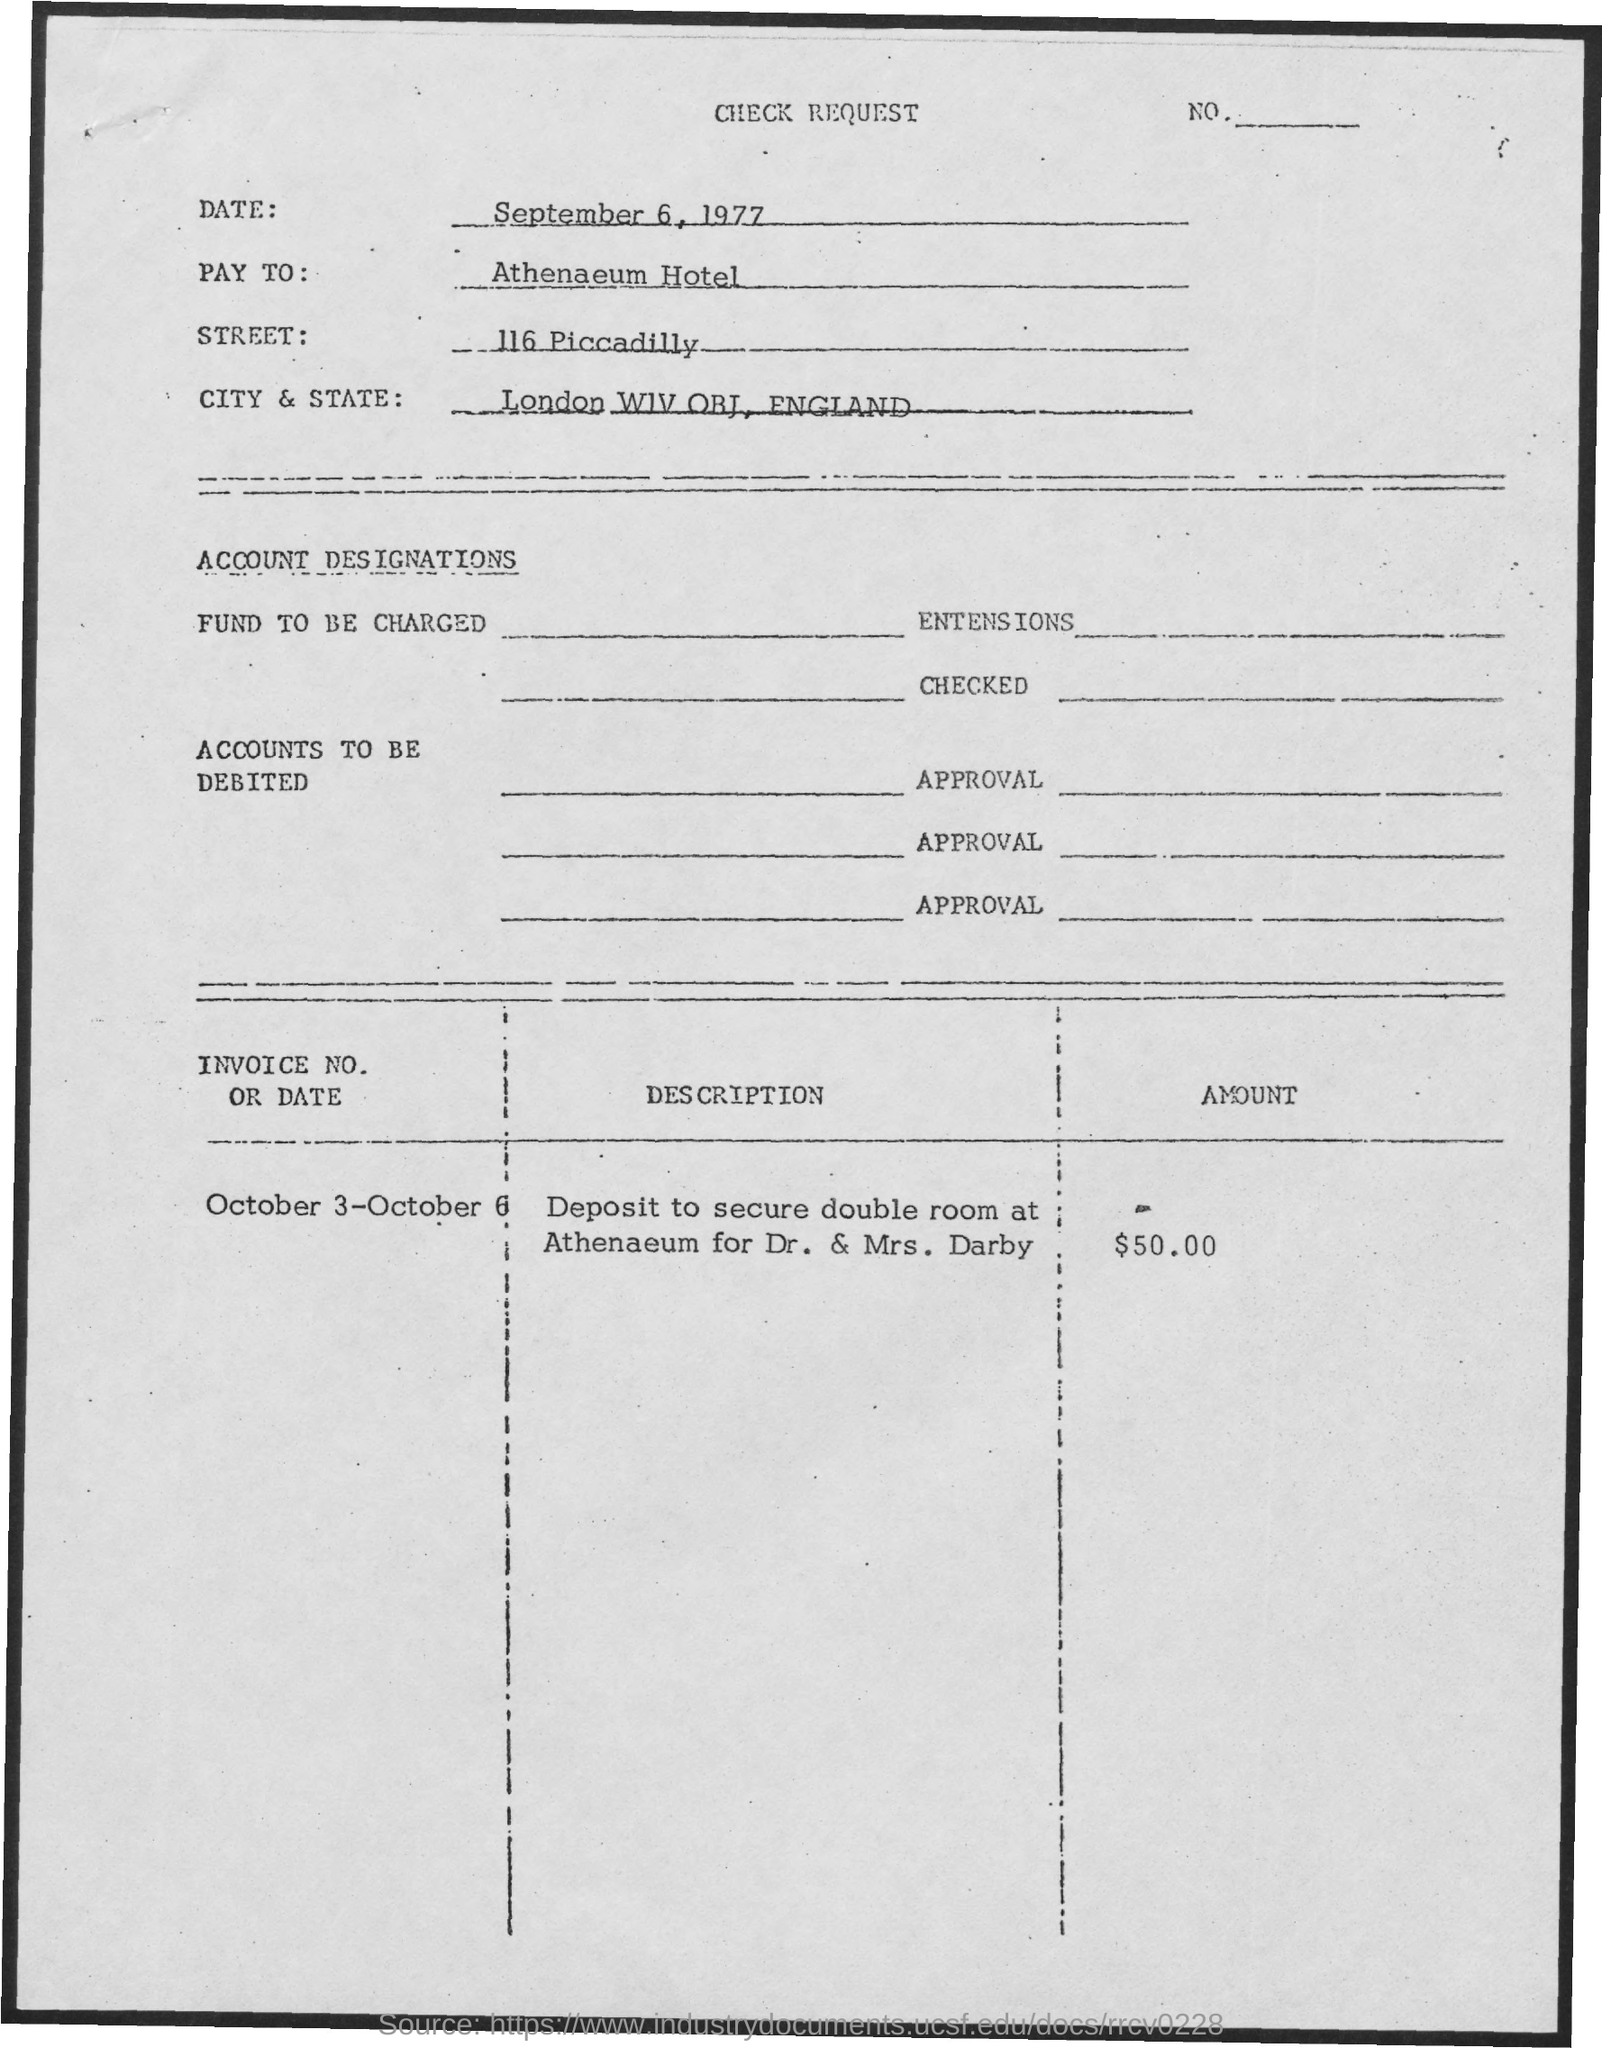List a handful of essential elements in this visual. The street is 116 Piccadilly. The Athenaeum Hotel is the "Pay To". The date is September 6, 1977. The amount is $50.00. 